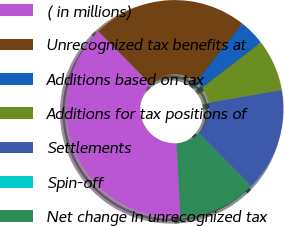<chart> <loc_0><loc_0><loc_500><loc_500><pie_chart><fcel>( in millions)<fcel>Unrecognized tax benefits at<fcel>Additions based on tax<fcel>Additions for tax positions of<fcel>Settlements<fcel>Spin-off<fcel>Net change in unrecognized tax<nl><fcel>38.43%<fcel>23.07%<fcel>3.86%<fcel>7.7%<fcel>15.38%<fcel>0.02%<fcel>11.54%<nl></chart> 